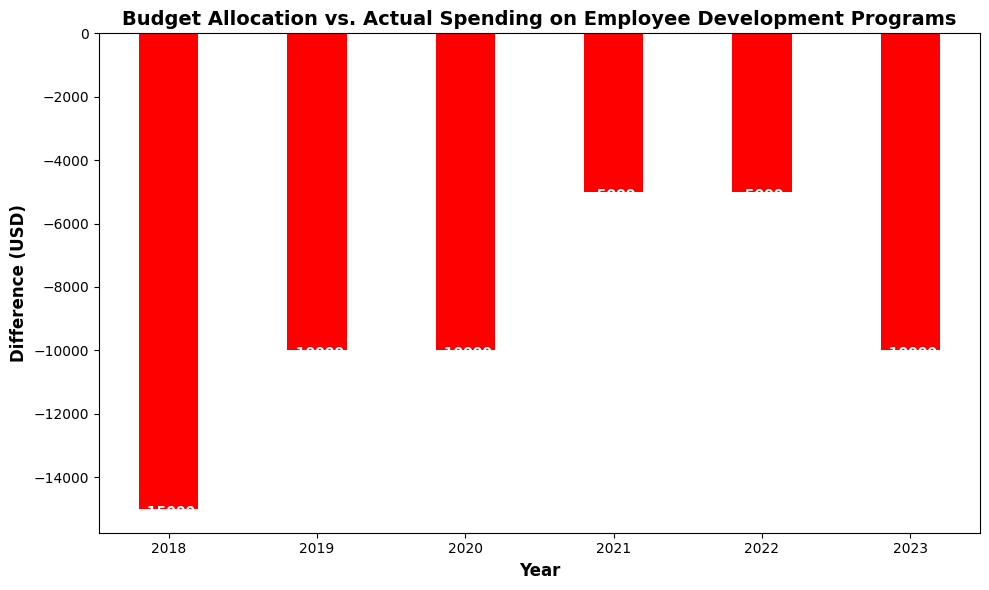What year had the largest positive difference between Budget Allocation and Actual Spending? The difference is positive if Actual Spending is greater than Budget Allocation. 2023 had a difference of 170000 - 180000 = -10000, 2022 had 155000 - 160000 = -5000, 2021 had 125000 - 130000 = -5000, 2020 had 140000 - 150000 = -10000, 2019 had 110000 - 120000 = -10000, and 2018 had 85000 - 100000 = -15000. So, 2022 and 2021 had the same positive difference of -5000, which is the largest.
Answer: 2022 and 2021 Which year had the smallest (most negative) difference between Budget Allocation and Actual Spending? To find the year with the smallest difference, we look for the most negative values. The difference values are -15000 (2018), -10000 (2019, 2020, 2023), and -5000 (2021, 2022). Therefore, 2018 had the smallest (most negative) difference.
Answer: 2018 What is the median difference between Budget Allocation and Actual Spending over the years? The differences are -15000 (2018), -10000 (2019), -10000 (2020), -5000 (2021), -5000 (2022), and -10000 (2023). Arranging them in order: -15000, -10000, -10000, -10000, -5000, -5000. The median is the average of the two middle values: (-10000 + -10000) / 2 = -10000.
Answer: -10000 By how much did Actual Spending fall short of the Budget Allocation in 2018? In 2018, Actual Spending was 85000 and Budget Allocation was 100000. The shortfall is 100000 - 85000 = 15000.
Answer: 15000 In which years was the Actual Spending below the Budget Allocation? Comparing Actual Spending to Budget Allocation for each year, we have: 2018 (85000 < 100000), 2019 (110000 < 120000), 2020 (140000 < 150000), 2021 (125000 < 130000), 2022 (155000 < 160000), and 2023 (170000 < 180000). All years have Actual Spending below Budget Allocation.
Answer: All years Which year had the least amount of shortfall between Budget Allocation and Actual Spending? The year with the smallest (least negative) difference is the one with the least amount of shortfall. We compare -15000 (2018), -10000 (2019), -10000 (2020), -5000 (2021), -5000 (2022), and -10000 (2023), 2022 and 2021 both have the smallest shortfall of -5000.
Answer: 2022 and 2021 What is the average difference between the Budget Allocation and Actual Spending over the years? To find the average difference, sum the differences and divide by the number of years: (-15000 - 10000 - 10000 - 5000 - 5000 - 10000) / 6 = (-55000) / 6 ≈ -9167.
Answer: -9167 